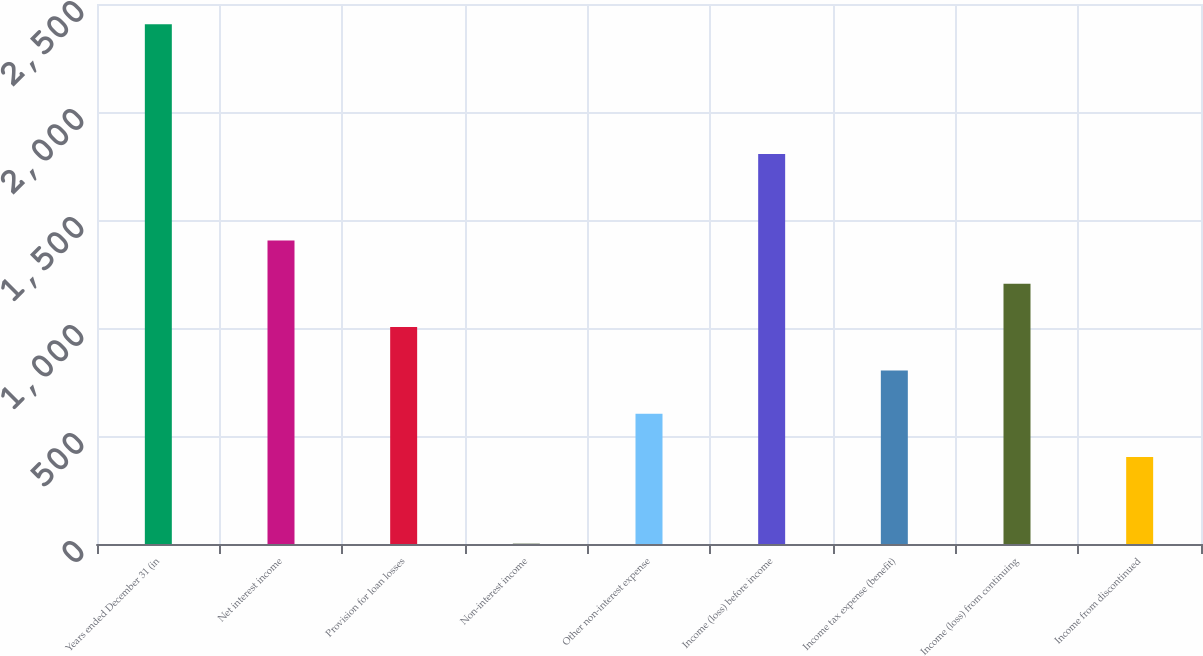Convert chart to OTSL. <chart><loc_0><loc_0><loc_500><loc_500><bar_chart><fcel>Years ended December 31 (in<fcel>Net interest income<fcel>Provision for loan losses<fcel>Non-interest income<fcel>Other non-interest expense<fcel>Income (loss) before income<fcel>Income tax expense (benefit)<fcel>Income (loss) from continuing<fcel>Income from discontinued<nl><fcel>2406.74<fcel>1404.89<fcel>1004.15<fcel>2.3<fcel>603.41<fcel>1805.63<fcel>803.78<fcel>1204.52<fcel>403.04<nl></chart> 